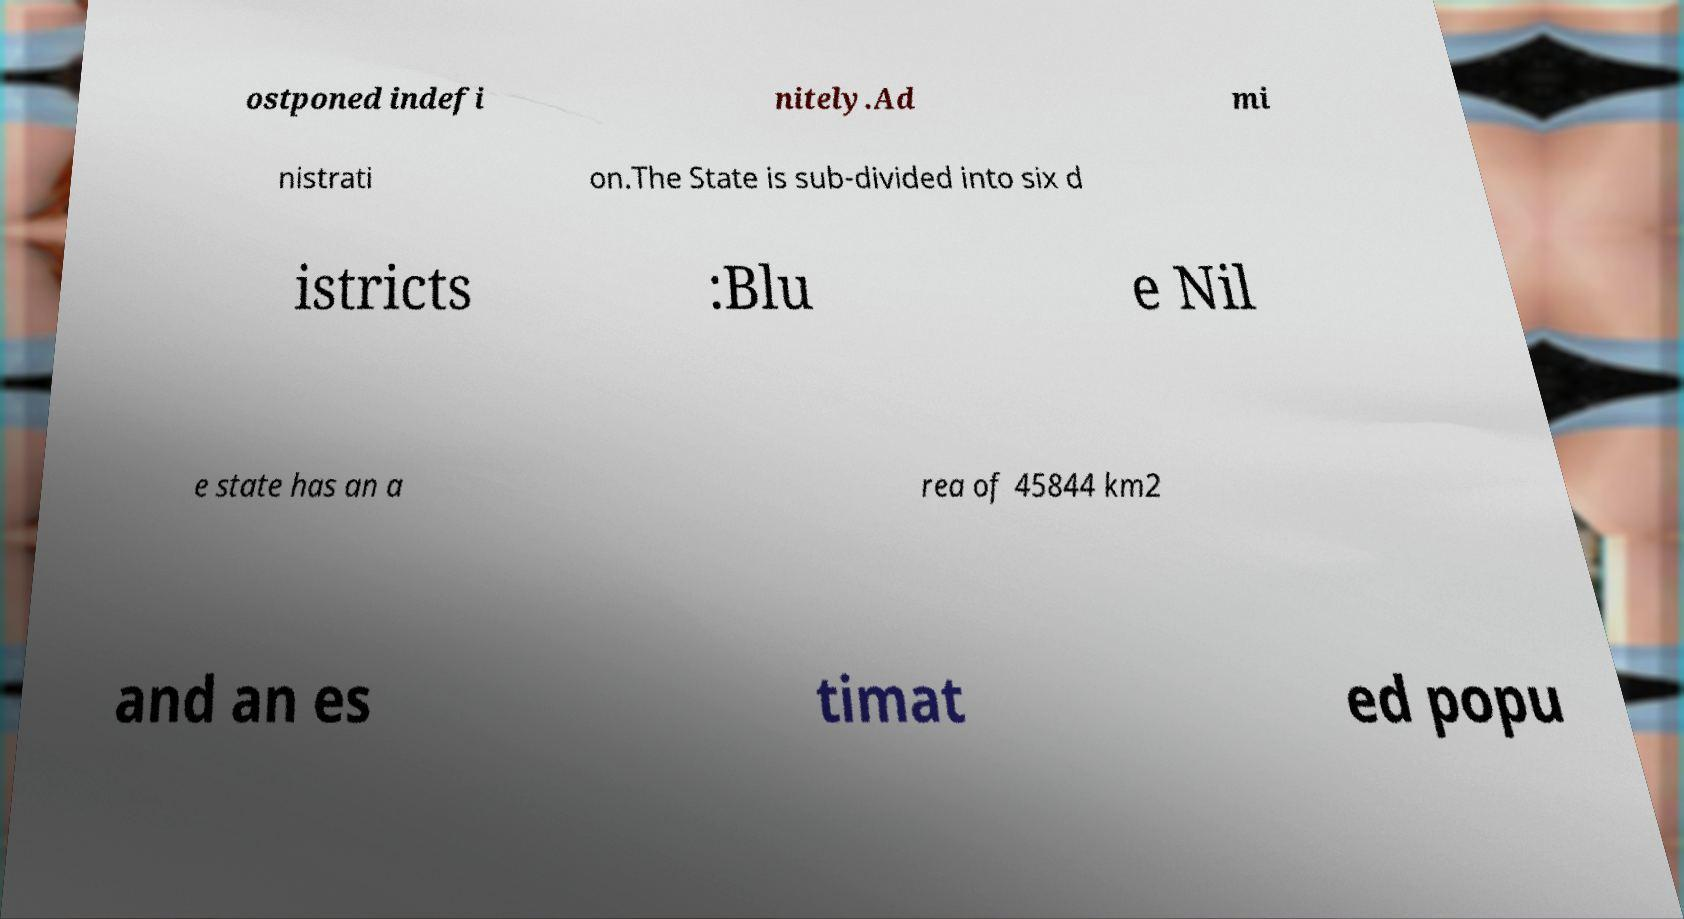Can you read and provide the text displayed in the image?This photo seems to have some interesting text. Can you extract and type it out for me? ostponed indefi nitely.Ad mi nistrati on.The State is sub-divided into six d istricts :Blu e Nil e state has an a rea of 45844 km2 and an es timat ed popu 